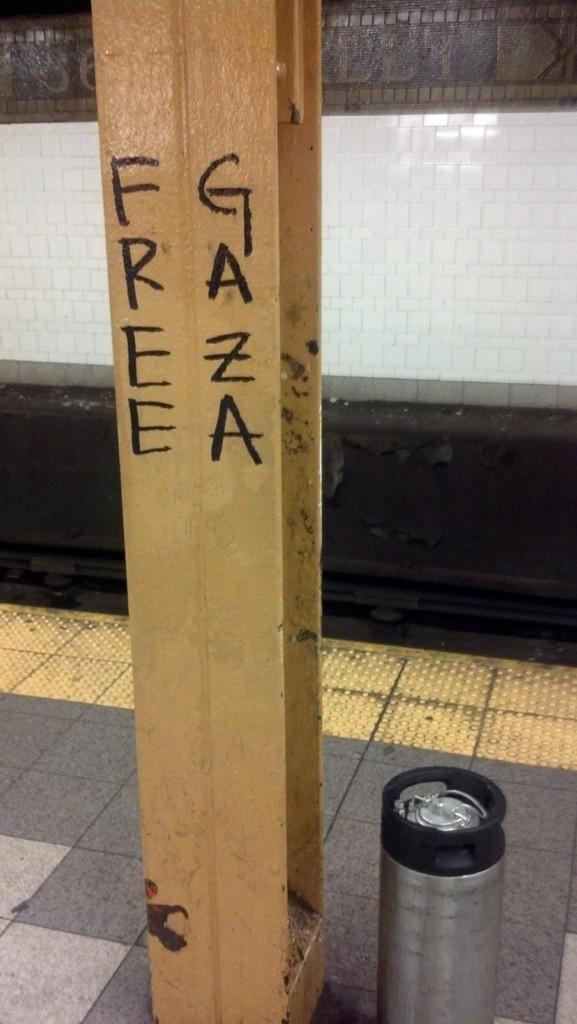What 2 words are written vertically on the post?
Offer a very short reply. Free gaza. 